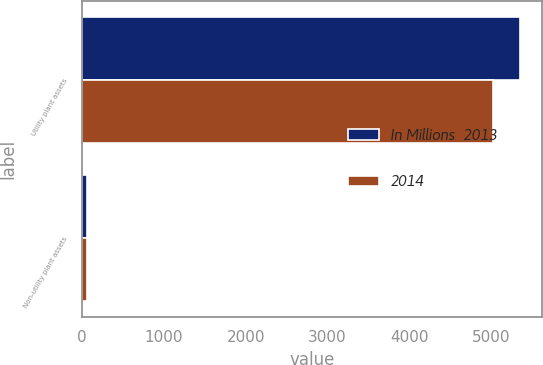Convert chart. <chart><loc_0><loc_0><loc_500><loc_500><stacked_bar_chart><ecel><fcel>Utility plant assets<fcel>Non-utility plant assets<nl><fcel>In Millions  2013<fcel>5345<fcel>70<nl><fcel>2014<fcel>5021<fcel>66<nl></chart> 